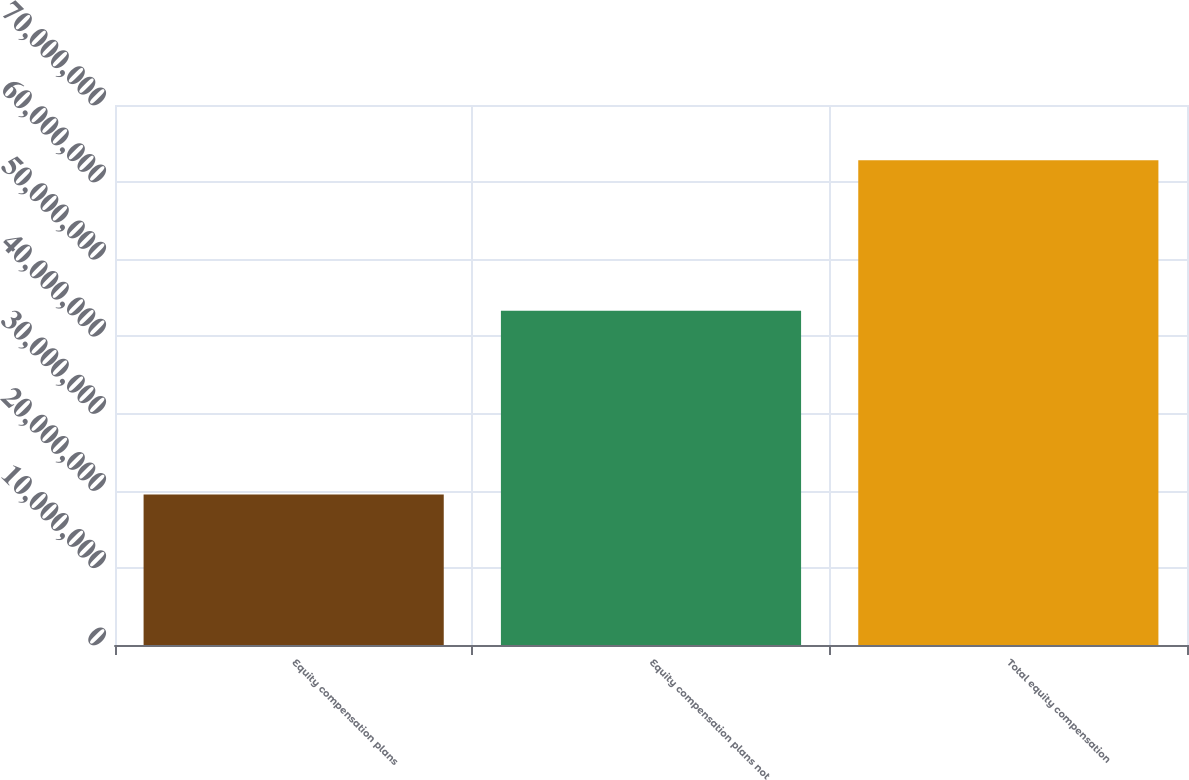Convert chart. <chart><loc_0><loc_0><loc_500><loc_500><bar_chart><fcel>Equity compensation plans<fcel>Equity compensation plans not<fcel>Total equity compensation<nl><fcel>1.95076e+07<fcel>4.33436e+07<fcel>6.28512e+07<nl></chart> 